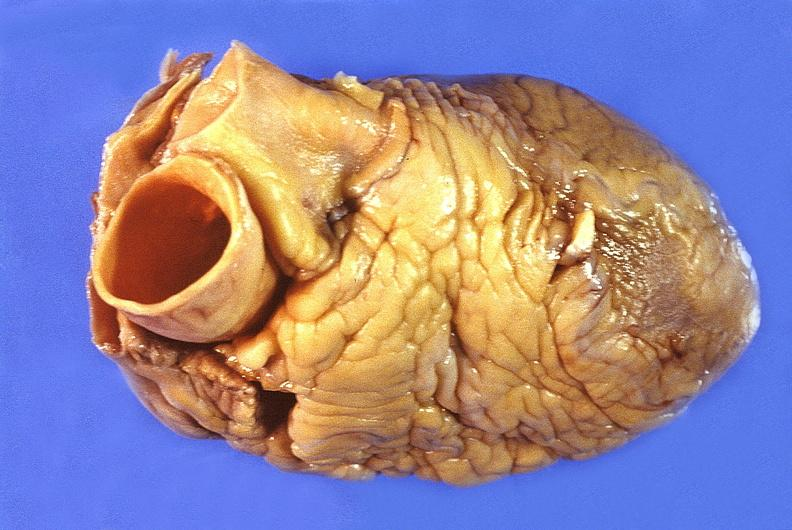does fat necrosis show normal cardiovascular?
Answer the question using a single word or phrase. No 